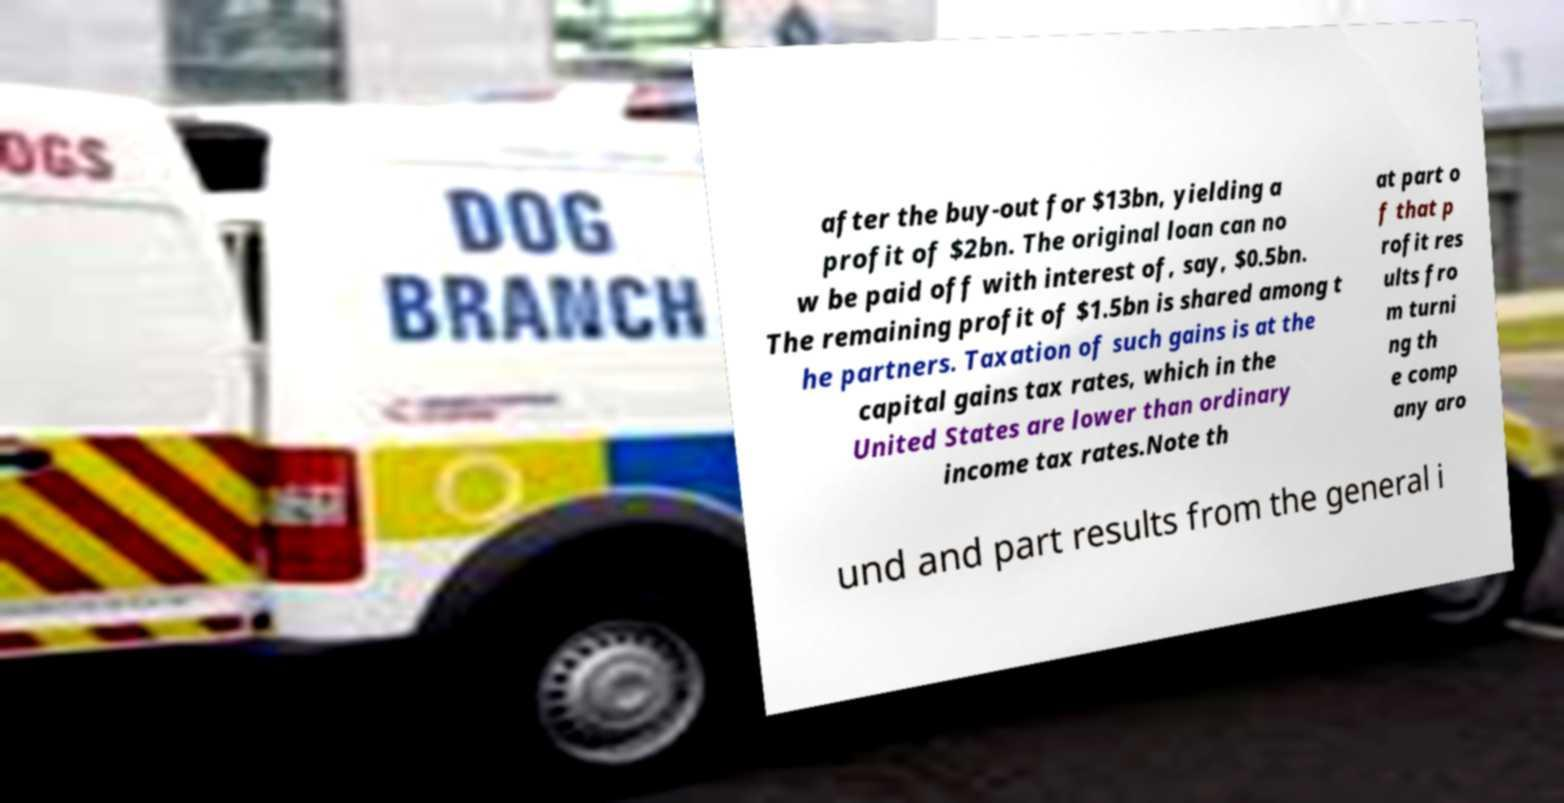I need the written content from this picture converted into text. Can you do that? after the buy-out for $13bn, yielding a profit of $2bn. The original loan can no w be paid off with interest of, say, $0.5bn. The remaining profit of $1.5bn is shared among t he partners. Taxation of such gains is at the capital gains tax rates, which in the United States are lower than ordinary income tax rates.Note th at part o f that p rofit res ults fro m turni ng th e comp any aro und and part results from the general i 